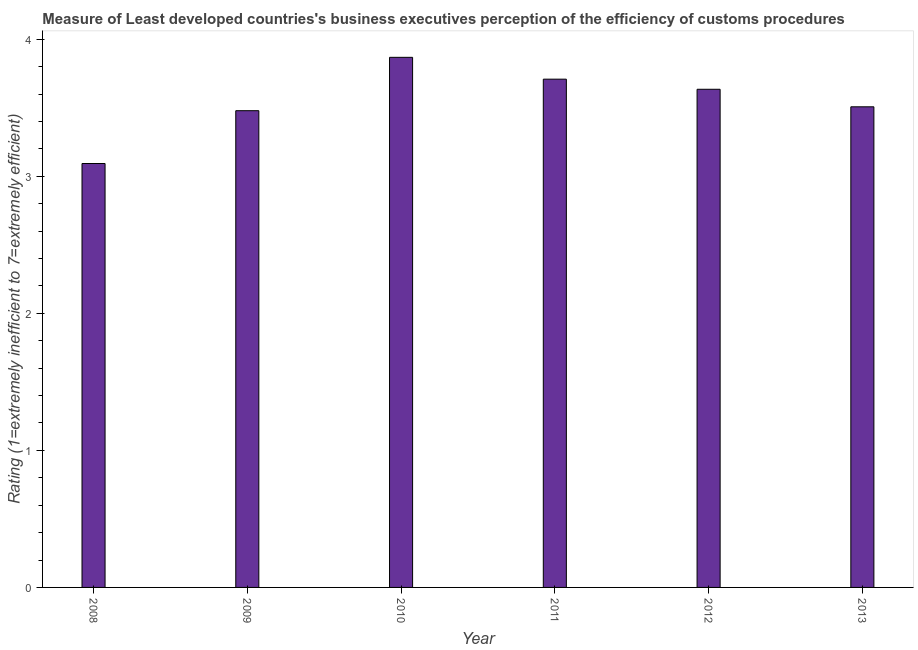Does the graph contain any zero values?
Make the answer very short. No. What is the title of the graph?
Give a very brief answer. Measure of Least developed countries's business executives perception of the efficiency of customs procedures. What is the label or title of the Y-axis?
Your answer should be very brief. Rating (1=extremely inefficient to 7=extremely efficient). What is the rating measuring burden of customs procedure in 2011?
Keep it short and to the point. 3.71. Across all years, what is the maximum rating measuring burden of customs procedure?
Your answer should be compact. 3.87. Across all years, what is the minimum rating measuring burden of customs procedure?
Your answer should be very brief. 3.09. In which year was the rating measuring burden of customs procedure minimum?
Your answer should be compact. 2008. What is the sum of the rating measuring burden of customs procedure?
Your answer should be compact. 21.29. What is the difference between the rating measuring burden of customs procedure in 2009 and 2012?
Ensure brevity in your answer.  -0.16. What is the average rating measuring burden of customs procedure per year?
Provide a short and direct response. 3.55. What is the median rating measuring burden of customs procedure?
Provide a short and direct response. 3.57. Is the rating measuring burden of customs procedure in 2009 less than that in 2013?
Offer a terse response. Yes. What is the difference between the highest and the second highest rating measuring burden of customs procedure?
Your answer should be compact. 0.16. What is the difference between the highest and the lowest rating measuring burden of customs procedure?
Ensure brevity in your answer.  0.77. In how many years, is the rating measuring burden of customs procedure greater than the average rating measuring burden of customs procedure taken over all years?
Offer a terse response. 3. How many bars are there?
Provide a short and direct response. 6. How many years are there in the graph?
Offer a terse response. 6. What is the difference between two consecutive major ticks on the Y-axis?
Provide a succinct answer. 1. Are the values on the major ticks of Y-axis written in scientific E-notation?
Provide a succinct answer. No. What is the Rating (1=extremely inefficient to 7=extremely efficient) in 2008?
Provide a short and direct response. 3.09. What is the Rating (1=extremely inefficient to 7=extremely efficient) of 2009?
Your answer should be very brief. 3.48. What is the Rating (1=extremely inefficient to 7=extremely efficient) in 2010?
Your response must be concise. 3.87. What is the Rating (1=extremely inefficient to 7=extremely efficient) in 2011?
Keep it short and to the point. 3.71. What is the Rating (1=extremely inefficient to 7=extremely efficient) in 2012?
Offer a terse response. 3.63. What is the Rating (1=extremely inefficient to 7=extremely efficient) in 2013?
Offer a very short reply. 3.51. What is the difference between the Rating (1=extremely inefficient to 7=extremely efficient) in 2008 and 2009?
Keep it short and to the point. -0.39. What is the difference between the Rating (1=extremely inefficient to 7=extremely efficient) in 2008 and 2010?
Give a very brief answer. -0.77. What is the difference between the Rating (1=extremely inefficient to 7=extremely efficient) in 2008 and 2011?
Keep it short and to the point. -0.62. What is the difference between the Rating (1=extremely inefficient to 7=extremely efficient) in 2008 and 2012?
Give a very brief answer. -0.54. What is the difference between the Rating (1=extremely inefficient to 7=extremely efficient) in 2008 and 2013?
Your answer should be compact. -0.41. What is the difference between the Rating (1=extremely inefficient to 7=extremely efficient) in 2009 and 2010?
Give a very brief answer. -0.39. What is the difference between the Rating (1=extremely inefficient to 7=extremely efficient) in 2009 and 2011?
Your answer should be very brief. -0.23. What is the difference between the Rating (1=extremely inefficient to 7=extremely efficient) in 2009 and 2012?
Provide a short and direct response. -0.16. What is the difference between the Rating (1=extremely inefficient to 7=extremely efficient) in 2009 and 2013?
Make the answer very short. -0.03. What is the difference between the Rating (1=extremely inefficient to 7=extremely efficient) in 2010 and 2011?
Give a very brief answer. 0.16. What is the difference between the Rating (1=extremely inefficient to 7=extremely efficient) in 2010 and 2012?
Provide a short and direct response. 0.23. What is the difference between the Rating (1=extremely inefficient to 7=extremely efficient) in 2010 and 2013?
Give a very brief answer. 0.36. What is the difference between the Rating (1=extremely inefficient to 7=extremely efficient) in 2011 and 2012?
Your answer should be very brief. 0.07. What is the difference between the Rating (1=extremely inefficient to 7=extremely efficient) in 2011 and 2013?
Offer a very short reply. 0.2. What is the difference between the Rating (1=extremely inefficient to 7=extremely efficient) in 2012 and 2013?
Give a very brief answer. 0.13. What is the ratio of the Rating (1=extremely inefficient to 7=extremely efficient) in 2008 to that in 2009?
Ensure brevity in your answer.  0.89. What is the ratio of the Rating (1=extremely inefficient to 7=extremely efficient) in 2008 to that in 2010?
Offer a terse response. 0.8. What is the ratio of the Rating (1=extremely inefficient to 7=extremely efficient) in 2008 to that in 2011?
Your response must be concise. 0.83. What is the ratio of the Rating (1=extremely inefficient to 7=extremely efficient) in 2008 to that in 2012?
Keep it short and to the point. 0.85. What is the ratio of the Rating (1=extremely inefficient to 7=extremely efficient) in 2008 to that in 2013?
Provide a short and direct response. 0.88. What is the ratio of the Rating (1=extremely inefficient to 7=extremely efficient) in 2009 to that in 2010?
Offer a very short reply. 0.9. What is the ratio of the Rating (1=extremely inefficient to 7=extremely efficient) in 2009 to that in 2011?
Ensure brevity in your answer.  0.94. What is the ratio of the Rating (1=extremely inefficient to 7=extremely efficient) in 2009 to that in 2012?
Your answer should be very brief. 0.96. What is the ratio of the Rating (1=extremely inefficient to 7=extremely efficient) in 2010 to that in 2011?
Offer a terse response. 1.04. What is the ratio of the Rating (1=extremely inefficient to 7=extremely efficient) in 2010 to that in 2012?
Make the answer very short. 1.06. What is the ratio of the Rating (1=extremely inefficient to 7=extremely efficient) in 2010 to that in 2013?
Provide a short and direct response. 1.1. What is the ratio of the Rating (1=extremely inefficient to 7=extremely efficient) in 2011 to that in 2013?
Give a very brief answer. 1.06. What is the ratio of the Rating (1=extremely inefficient to 7=extremely efficient) in 2012 to that in 2013?
Provide a succinct answer. 1.04. 